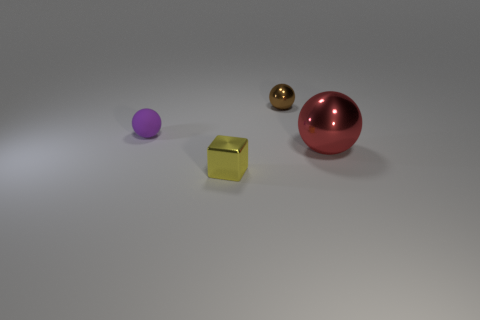Add 4 small purple balls. How many objects exist? 8 Subtract all cubes. How many objects are left? 3 Subtract all large red spheres. Subtract all red metallic spheres. How many objects are left? 2 Add 1 tiny yellow metal objects. How many tiny yellow metal objects are left? 2 Add 2 cyan shiny cylinders. How many cyan shiny cylinders exist? 2 Subtract 0 red cubes. How many objects are left? 4 